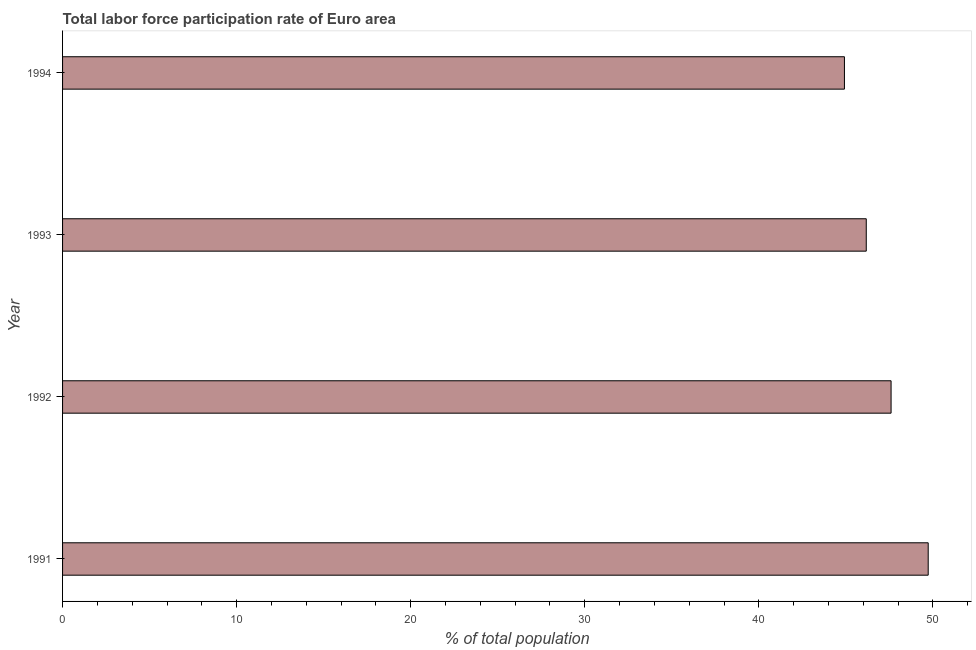What is the title of the graph?
Your answer should be compact. Total labor force participation rate of Euro area. What is the label or title of the X-axis?
Make the answer very short. % of total population. What is the total labor force participation rate in 1991?
Your response must be concise. 49.73. Across all years, what is the maximum total labor force participation rate?
Offer a very short reply. 49.73. Across all years, what is the minimum total labor force participation rate?
Keep it short and to the point. 44.91. In which year was the total labor force participation rate maximum?
Your answer should be compact. 1991. What is the sum of the total labor force participation rate?
Ensure brevity in your answer.  188.4. What is the difference between the total labor force participation rate in 1991 and 1993?
Your answer should be compact. 3.56. What is the average total labor force participation rate per year?
Your response must be concise. 47.1. What is the median total labor force participation rate?
Give a very brief answer. 46.88. In how many years, is the total labor force participation rate greater than 12 %?
Make the answer very short. 4. What is the ratio of the total labor force participation rate in 1991 to that in 1992?
Offer a very short reply. 1.04. What is the difference between the highest and the second highest total labor force participation rate?
Offer a very short reply. 2.13. What is the difference between the highest and the lowest total labor force participation rate?
Offer a terse response. 4.81. How many bars are there?
Provide a succinct answer. 4. Are all the bars in the graph horizontal?
Keep it short and to the point. Yes. Are the values on the major ticks of X-axis written in scientific E-notation?
Keep it short and to the point. No. What is the % of total population in 1991?
Ensure brevity in your answer.  49.73. What is the % of total population in 1992?
Make the answer very short. 47.59. What is the % of total population of 1993?
Offer a very short reply. 46.17. What is the % of total population in 1994?
Provide a short and direct response. 44.91. What is the difference between the % of total population in 1991 and 1992?
Your response must be concise. 2.13. What is the difference between the % of total population in 1991 and 1993?
Offer a very short reply. 3.56. What is the difference between the % of total population in 1991 and 1994?
Give a very brief answer. 4.81. What is the difference between the % of total population in 1992 and 1993?
Offer a terse response. 1.43. What is the difference between the % of total population in 1992 and 1994?
Provide a succinct answer. 2.68. What is the difference between the % of total population in 1993 and 1994?
Your response must be concise. 1.25. What is the ratio of the % of total population in 1991 to that in 1992?
Your answer should be compact. 1.04. What is the ratio of the % of total population in 1991 to that in 1993?
Your response must be concise. 1.08. What is the ratio of the % of total population in 1991 to that in 1994?
Offer a very short reply. 1.11. What is the ratio of the % of total population in 1992 to that in 1993?
Make the answer very short. 1.03. What is the ratio of the % of total population in 1992 to that in 1994?
Offer a terse response. 1.06. What is the ratio of the % of total population in 1993 to that in 1994?
Provide a succinct answer. 1.03. 